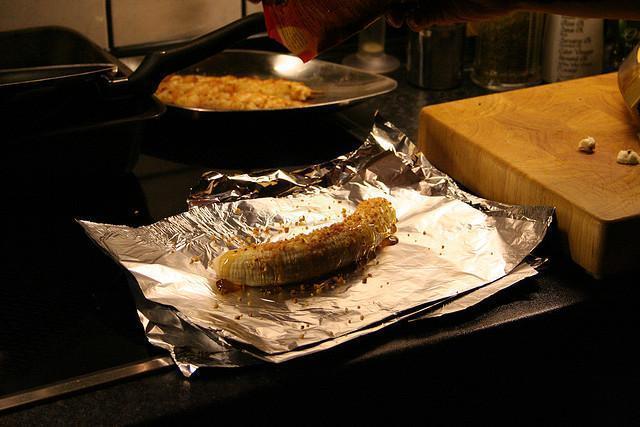How many sheets of tinfoil are there?
Give a very brief answer. 3. How many bottles are in the picture?
Give a very brief answer. 2. How many tires does the bike in the forefront have?
Give a very brief answer. 0. 